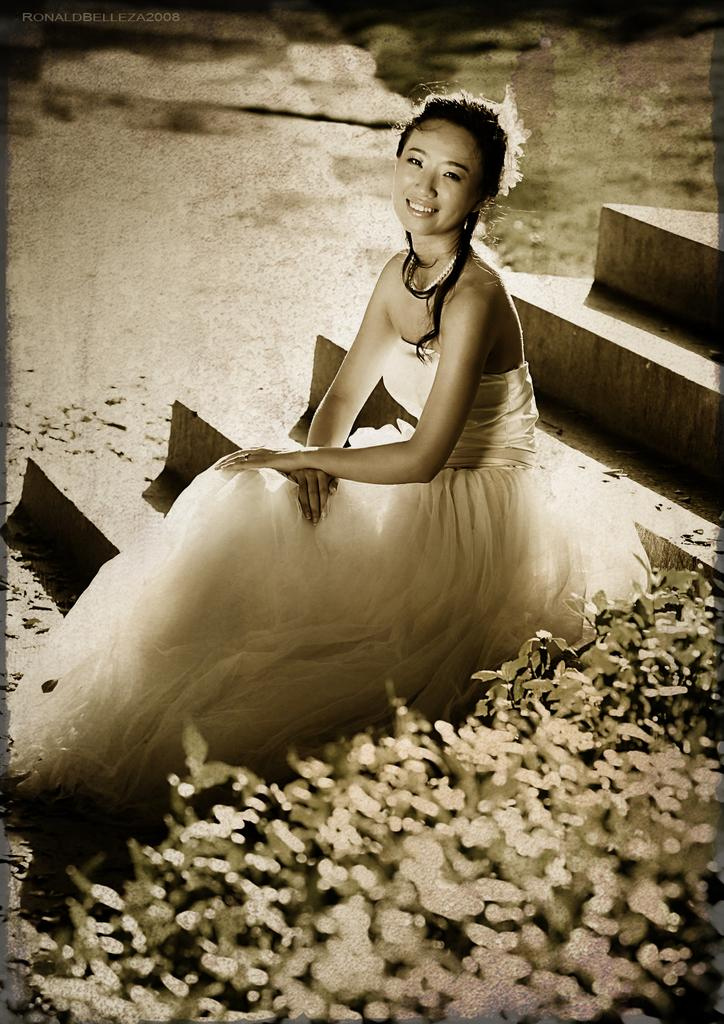Who is the main subject in the image? There is a woman in the image. What is the woman wearing? The woman is wearing a white gown. Where is the woman sitting in the image? The woman is sitting on a staircase. What can be seen on the right side of the image? There are plants on the right side of the image. Is the woman driving a car in the image? No, the woman is not driving a car in the image; she is sitting on a staircase. How many geese are present in the image? There are no geese present in the image. 